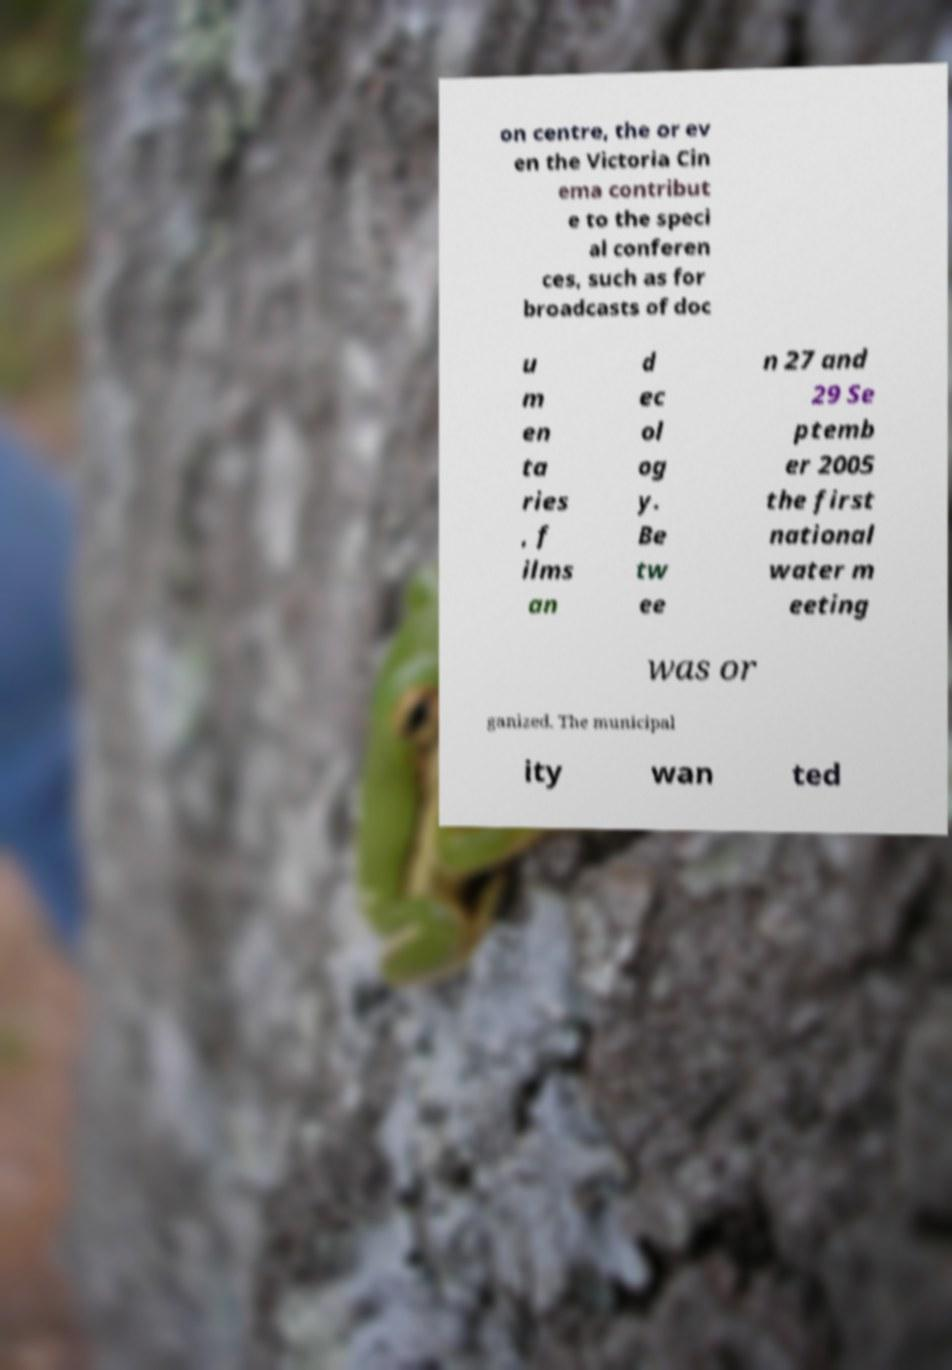Can you accurately transcribe the text from the provided image for me? on centre, the or ev en the Victoria Cin ema contribut e to the speci al conferen ces, such as for broadcasts of doc u m en ta ries , f ilms an d ec ol og y. Be tw ee n 27 and 29 Se ptemb er 2005 the first national water m eeting was or ganized. The municipal ity wan ted 